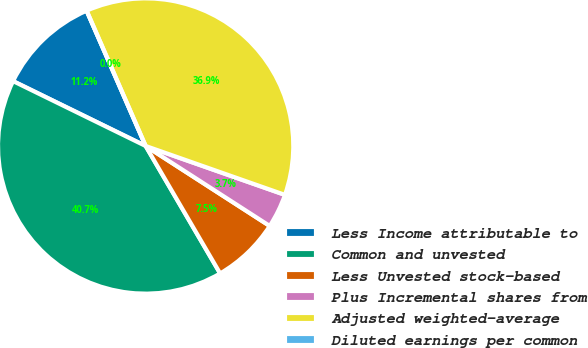Convert chart. <chart><loc_0><loc_0><loc_500><loc_500><pie_chart><fcel>Less Income attributable to<fcel>Common and unvested<fcel>Less Unvested stock-based<fcel>Plus Incremental shares from<fcel>Adjusted weighted-average<fcel>Diluted earnings per common<nl><fcel>11.21%<fcel>40.66%<fcel>7.47%<fcel>3.74%<fcel>36.92%<fcel>0.0%<nl></chart> 